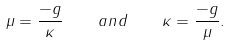<formula> <loc_0><loc_0><loc_500><loc_500>\mu = \frac { - g } { \kappa } \quad a n d \quad \kappa = \frac { - g } { \mu } .</formula> 